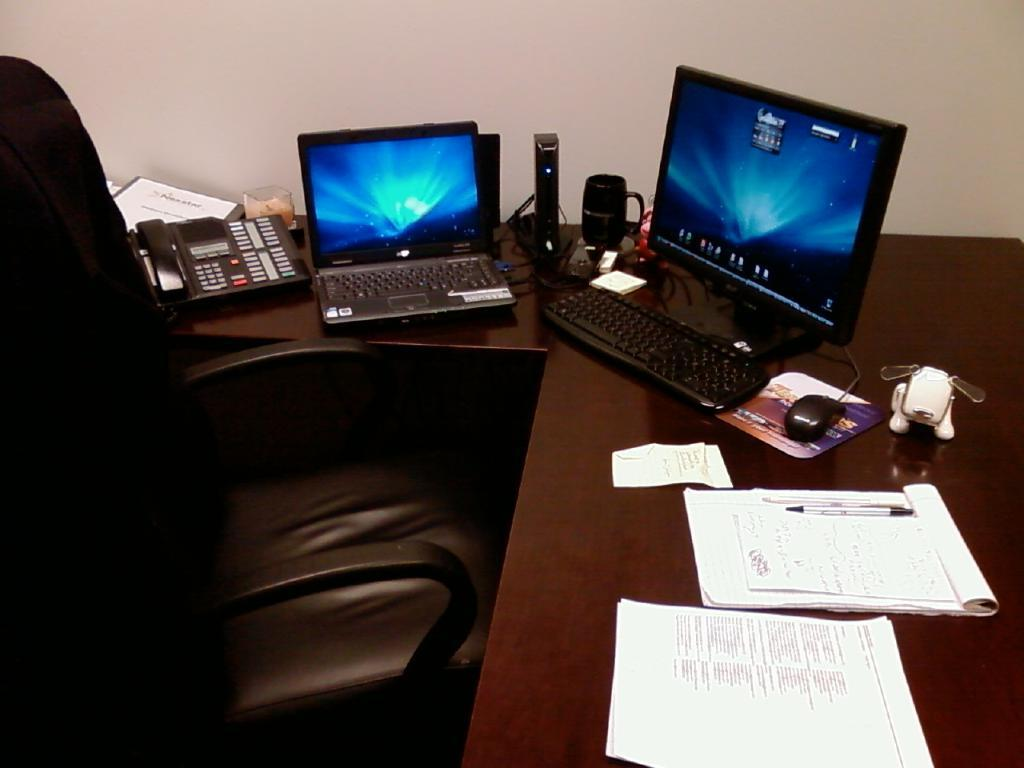What type of furniture is in the image? There is a chair in the image. Where is the chair located in relation to other objects? The chair is in front of a table. What electronic devices are on the table? There is a computer and a laptop on the table. What else can be found on the table besides electronic devices? There are papers and other objects on the table. What type of quiver is hanging on the wall in the image? There is no quiver present in the image. What nation is represented by the flag on the table in the image? There is no flag present on the table in the image. 